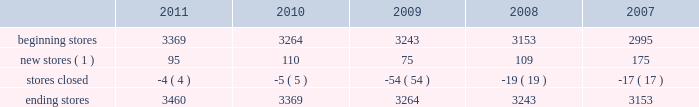The table sets forth information concerning increases in the total number of our aap stores during the past five years : beginning stores new stores ( 1 ) stores closed ending stores ( 1 ) does not include stores that opened as relocations of previously existing stores within the same general market area or substantial renovations of stores .
Our store-based information systems , which are designed to improve the efficiency of our operations and enhance customer service , are comprised of a proprietary pos system and electronic parts catalog , or epc , system .
Information maintained by our pos system is used to formulate pricing , marketing and merchandising strategies and to replenish inventory accurately and rapidly .
Our pos system is fully integrated with our epc system and enables our store team members to assist our customers in their parts selection and ordering based on the year , make , model and engine type of their vehicles .
Our centrally-based epc data management system enables us to reduce the time needed to ( i ) exchange data with our vendors and ( ii ) catalog and deliver updated , accurate parts information .
Our epc system also contains enhanced search engines and user-friendly navigation tools that enhance our team members' ability to look up any needed parts as well as additional products the customer needs to complete an automotive repair project .
If a hard-to-find part or accessory is not available at one of our stores , the epc system can determine whether the part is carried and in-stock through our hub or pdq ae networks or can be ordered directly from one of our vendors .
Available parts and accessories are then ordered electronically from another store , hub , pdq ae or directly from the vendor with immediate confirmation of price , availability and estimated delivery time .
We also support our store operations with additional proprietary systems and customer driven labor scheduling capabilities .
Our store-level inventory management system provides real-time inventory tracking at the store level .
With the store-level system , store team members can check the quantity of on-hand inventory for any sku , adjust stock levels for select items for store specific events , automatically process returns and defective merchandise , designate skus for cycle counts and track merchandise transfers .
Our stores use radio frequency hand-held devices to help ensure the accuracy of our inventory .
Our standard operating procedure , or sop , system is a web-based , electronic data management system that provides our team members with instant access to any of our standard operating procedures through a comprehensive on-line search function .
All of these systems are tightly integrated and provide real-time , comprehensive information to store personnel , resulting in improved customer service levels , team member productivity and in-stock availability .
Purchasing for virtually all of the merchandise for our stores is handled by our merchandise teams located in three primary locations : 2022 store support center in roanoke , virginia ; 2022 regional office in minneapolis , minnesota ; and 2022 global sourcing office in taipei , taiwan .
Our roanoke team is primarily responsible for the parts categories and our minnesota team is primarily responsible for accessories , oil and chemicals .
Our global sourcing team works closely with both teams .
In fiscal 2011 , we purchased merchandise from approximately 500 vendors , with no single vendor accounting for more than 9% ( 9 % ) of purchases .
Our purchasing strategy involves negotiating agreements with most of our vendors to purchase merchandise over a specified period of time along with other terms , including pricing , payment terms and volume .
The merchandising team has developed strong vendor relationships in the industry and , in a collaborative effort with our vendor partners , utilizes a category management process where we manage the mix of our product offerings to meet customer demand .
We believe this process , which develops a customer-focused business plan for each merchandise category , and our global sourcing operation are critical to improving comparable store sales , gross margin and inventory productivity. .
The following table sets forth information concerning increases in the total number of our aap stores during the past five years : beginning stores new stores ( 1 ) stores closed ending stores ( 1 ) does not include stores that opened as relocations of previously existing stores within the same general market area or substantial renovations of stores .
Our store-based information systems , which are designed to improve the efficiency of our operations and enhance customer service , are comprised of a proprietary pos system and electronic parts catalog , or epc , system .
Information maintained by our pos system is used to formulate pricing , marketing and merchandising strategies and to replenish inventory accurately and rapidly .
Our pos system is fully integrated with our epc system and enables our store team members to assist our customers in their parts selection and ordering based on the year , make , model and engine type of their vehicles .
Our centrally-based epc data management system enables us to reduce the time needed to ( i ) exchange data with our vendors and ( ii ) catalog and deliver updated , accurate parts information .
Our epc system also contains enhanced search engines and user-friendly navigation tools that enhance our team members' ability to look up any needed parts as well as additional products the customer needs to complete an automotive repair project .
If a hard-to-find part or accessory is not available at one of our stores , the epc system can determine whether the part is carried and in-stock through our hub or pdq ae networks or can be ordered directly from one of our vendors .
Available parts and accessories are then ordered electronically from another store , hub , pdq ae or directly from the vendor with immediate confirmation of price , availability and estimated delivery time .
We also support our store operations with additional proprietary systems and customer driven labor scheduling capabilities .
Our store-level inventory management system provides real-time inventory tracking at the store level .
With the store-level system , store team members can check the quantity of on-hand inventory for any sku , adjust stock levels for select items for store specific events , automatically process returns and defective merchandise , designate skus for cycle counts and track merchandise transfers .
Our stores use radio frequency hand-held devices to help ensure the accuracy of our inventory .
Our standard operating procedure , or sop , system is a web-based , electronic data management system that provides our team members with instant access to any of our standard operating procedures through a comprehensive on-line search function .
All of these systems are tightly integrated and provide real-time , comprehensive information to store personnel , resulting in improved customer service levels , team member productivity and in-stock availability .
Purchasing for virtually all of the merchandise for our stores is handled by our merchandise teams located in three primary locations : 2022 store support center in roanoke , virginia ; 2022 regional office in minneapolis , minnesota ; and 2022 global sourcing office in taipei , taiwan .
Our roanoke team is primarily responsible for the parts categories and our minnesota team is primarily responsible for accessories , oil and chemicals .
Our global sourcing team works closely with both teams .
In fiscal 2011 , we purchased merchandise from approximately 500 vendors , with no single vendor accounting for more than 9% ( 9 % ) of purchases .
Our purchasing strategy involves negotiating agreements with most of our vendors to purchase merchandise over a specified period of time along with other terms , including pricing , payment terms and volume .
The merchandising team has developed strong vendor relationships in the industry and , in a collaborative effort with our vendor partners , utilizes a category management process where we manage the mix of our product offerings to meet customer demand .
We believe this process , which develops a customer-focused business plan for each merchandise category , and our global sourcing operation are critical to improving comparable store sales , gross margin and inventory productivity. .
What is the net number of stores that opened during 2010? 
Computations: (110 - 5)
Answer: 105.0. 